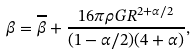Convert formula to latex. <formula><loc_0><loc_0><loc_500><loc_500>\beta = \overline { \beta } + \frac { 1 6 \pi \rho G R ^ { 2 + \alpha / 2 } } { ( 1 - \alpha / 2 ) ( 4 + \alpha ) } ,</formula> 